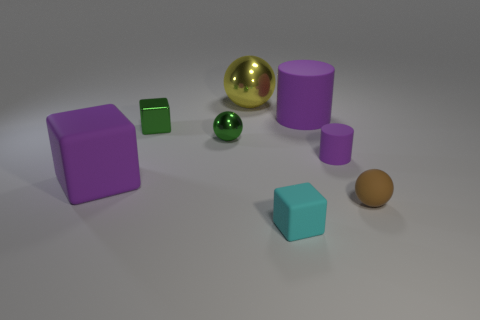Subtract all small cyan blocks. How many blocks are left? 2 Add 1 purple cubes. How many objects exist? 9 Subtract all cylinders. How many objects are left? 6 Add 6 large spheres. How many large spheres exist? 7 Subtract 1 brown balls. How many objects are left? 7 Subtract all tiny green things. Subtract all rubber cubes. How many objects are left? 4 Add 8 big purple cubes. How many big purple cubes are left? 9 